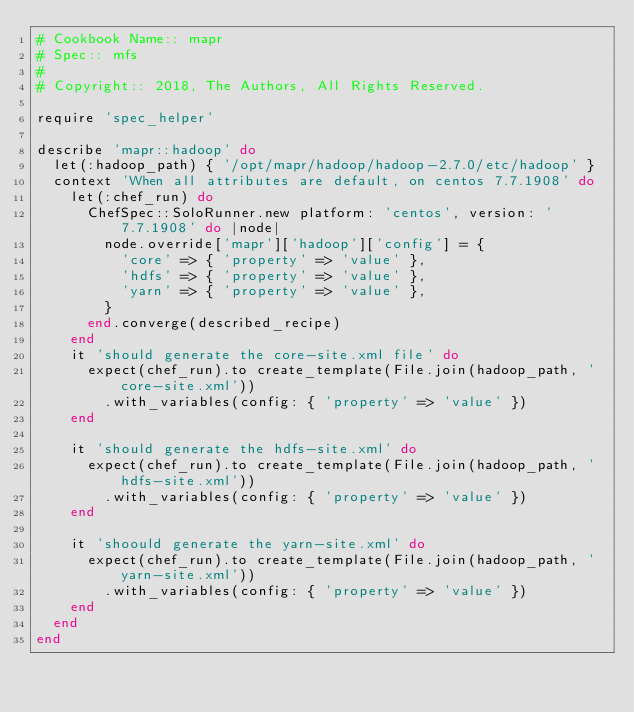<code> <loc_0><loc_0><loc_500><loc_500><_Ruby_># Cookbook Name:: mapr
# Spec:: mfs
#
# Copyright:: 2018, The Authors, All Rights Reserved.

require 'spec_helper'

describe 'mapr::hadoop' do
  let(:hadoop_path) { '/opt/mapr/hadoop/hadoop-2.7.0/etc/hadoop' }
  context 'When all attributes are default, on centos 7.7.1908' do
    let(:chef_run) do
      ChefSpec::SoloRunner.new platform: 'centos', version: '7.7.1908' do |node|
        node.override['mapr']['hadoop']['config'] = {
          'core' => { 'property' => 'value' },
          'hdfs' => { 'property' => 'value' },
          'yarn' => { 'property' => 'value' },
        }
      end.converge(described_recipe)
    end
    it 'should generate the core-site.xml file' do
      expect(chef_run).to create_template(File.join(hadoop_path, 'core-site.xml'))
        .with_variables(config: { 'property' => 'value' })
    end

    it 'should generate the hdfs-site.xml' do
      expect(chef_run).to create_template(File.join(hadoop_path, 'hdfs-site.xml'))
        .with_variables(config: { 'property' => 'value' })
    end

    it 'shoould generate the yarn-site.xml' do
      expect(chef_run).to create_template(File.join(hadoop_path, 'yarn-site.xml'))
        .with_variables(config: { 'property' => 'value' })
    end
  end
end
</code> 